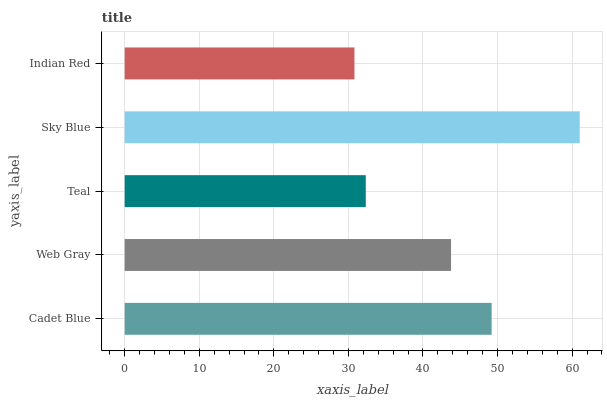Is Indian Red the minimum?
Answer yes or no. Yes. Is Sky Blue the maximum?
Answer yes or no. Yes. Is Web Gray the minimum?
Answer yes or no. No. Is Web Gray the maximum?
Answer yes or no. No. Is Cadet Blue greater than Web Gray?
Answer yes or no. Yes. Is Web Gray less than Cadet Blue?
Answer yes or no. Yes. Is Web Gray greater than Cadet Blue?
Answer yes or no. No. Is Cadet Blue less than Web Gray?
Answer yes or no. No. Is Web Gray the high median?
Answer yes or no. Yes. Is Web Gray the low median?
Answer yes or no. Yes. Is Indian Red the high median?
Answer yes or no. No. Is Teal the low median?
Answer yes or no. No. 